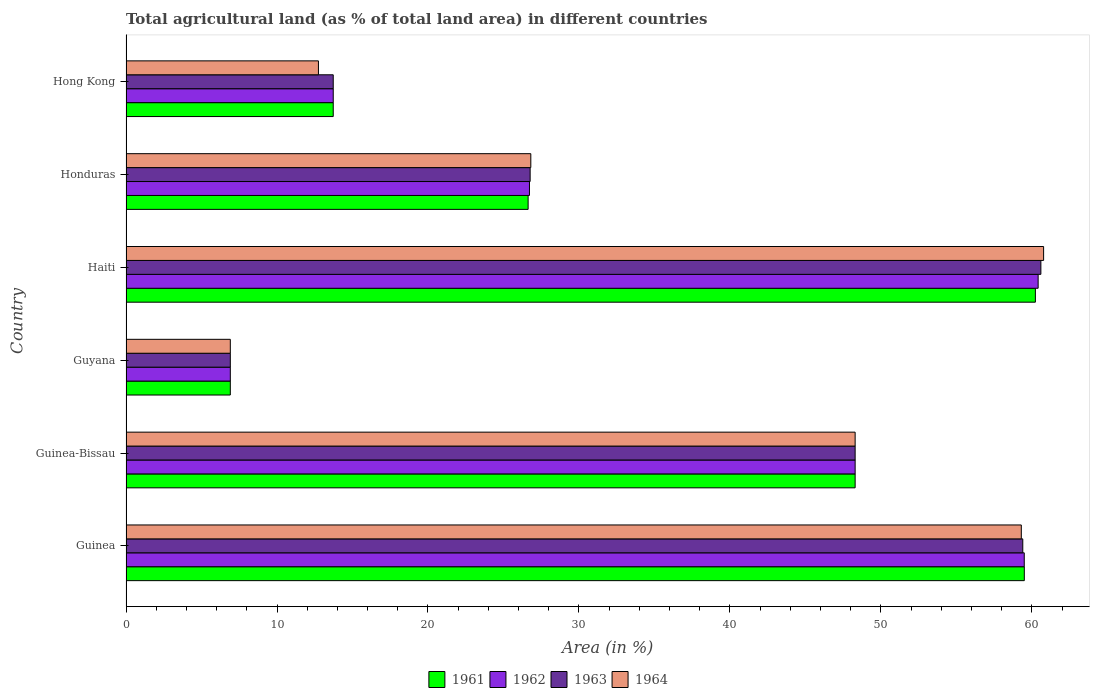How many groups of bars are there?
Your response must be concise. 6. What is the label of the 3rd group of bars from the top?
Your response must be concise. Haiti. In how many cases, is the number of bars for a given country not equal to the number of legend labels?
Your answer should be very brief. 0. What is the percentage of agricultural land in 1963 in Hong Kong?
Offer a very short reply. 13.73. Across all countries, what is the maximum percentage of agricultural land in 1961?
Provide a succinct answer. 60.23. Across all countries, what is the minimum percentage of agricultural land in 1961?
Make the answer very short. 6.91. In which country was the percentage of agricultural land in 1963 maximum?
Provide a succinct answer. Haiti. In which country was the percentage of agricultural land in 1964 minimum?
Keep it short and to the point. Guyana. What is the total percentage of agricultural land in 1962 in the graph?
Ensure brevity in your answer.  215.56. What is the difference between the percentage of agricultural land in 1963 in Guinea-Bissau and that in Hong Kong?
Ensure brevity in your answer.  34.57. What is the difference between the percentage of agricultural land in 1964 in Honduras and the percentage of agricultural land in 1961 in Hong Kong?
Offer a terse response. 13.09. What is the average percentage of agricultural land in 1963 per country?
Make the answer very short. 35.95. What is the difference between the percentage of agricultural land in 1964 and percentage of agricultural land in 1963 in Guinea?
Your response must be concise. -0.1. In how many countries, is the percentage of agricultural land in 1964 greater than 60 %?
Offer a very short reply. 1. What is the ratio of the percentage of agricultural land in 1963 in Haiti to that in Hong Kong?
Your answer should be very brief. 4.41. Is the percentage of agricultural land in 1962 in Guyana less than that in Hong Kong?
Offer a terse response. Yes. What is the difference between the highest and the second highest percentage of agricultural land in 1961?
Your answer should be compact. 0.73. What is the difference between the highest and the lowest percentage of agricultural land in 1964?
Make the answer very short. 53.87. Is the sum of the percentage of agricultural land in 1962 in Guinea-Bissau and Honduras greater than the maximum percentage of agricultural land in 1961 across all countries?
Your answer should be compact. Yes. Is it the case that in every country, the sum of the percentage of agricultural land in 1961 and percentage of agricultural land in 1964 is greater than the sum of percentage of agricultural land in 1963 and percentage of agricultural land in 1962?
Your answer should be very brief. No. What does the 3rd bar from the top in Guinea represents?
Your answer should be very brief. 1962. What does the 3rd bar from the bottom in Haiti represents?
Keep it short and to the point. 1963. Is it the case that in every country, the sum of the percentage of agricultural land in 1962 and percentage of agricultural land in 1963 is greater than the percentage of agricultural land in 1964?
Offer a very short reply. Yes. Does the graph contain grids?
Give a very brief answer. No. Where does the legend appear in the graph?
Your response must be concise. Bottom center. How many legend labels are there?
Your answer should be compact. 4. What is the title of the graph?
Ensure brevity in your answer.  Total agricultural land (as % of total land area) in different countries. Does "2000" appear as one of the legend labels in the graph?
Offer a very short reply. No. What is the label or title of the X-axis?
Provide a succinct answer. Area (in %). What is the Area (in %) in 1961 in Guinea?
Offer a terse response. 59.5. What is the Area (in %) in 1962 in Guinea?
Offer a very short reply. 59.49. What is the Area (in %) of 1963 in Guinea?
Offer a very short reply. 59.4. What is the Area (in %) of 1964 in Guinea?
Your answer should be compact. 59.3. What is the Area (in %) of 1961 in Guinea-Bissau?
Keep it short and to the point. 48.29. What is the Area (in %) of 1962 in Guinea-Bissau?
Give a very brief answer. 48.29. What is the Area (in %) of 1963 in Guinea-Bissau?
Offer a very short reply. 48.29. What is the Area (in %) of 1964 in Guinea-Bissau?
Provide a short and direct response. 48.29. What is the Area (in %) of 1961 in Guyana?
Your answer should be very brief. 6.91. What is the Area (in %) in 1962 in Guyana?
Provide a short and direct response. 6.91. What is the Area (in %) in 1963 in Guyana?
Your answer should be compact. 6.91. What is the Area (in %) of 1964 in Guyana?
Provide a short and direct response. 6.91. What is the Area (in %) of 1961 in Haiti?
Offer a terse response. 60.23. What is the Area (in %) of 1962 in Haiti?
Your answer should be very brief. 60.41. What is the Area (in %) in 1963 in Haiti?
Your answer should be compact. 60.6. What is the Area (in %) in 1964 in Haiti?
Provide a short and direct response. 60.78. What is the Area (in %) of 1961 in Honduras?
Ensure brevity in your answer.  26.63. What is the Area (in %) in 1962 in Honduras?
Your response must be concise. 26.72. What is the Area (in %) of 1963 in Honduras?
Provide a succinct answer. 26.77. What is the Area (in %) in 1964 in Honduras?
Offer a very short reply. 26.81. What is the Area (in %) in 1961 in Hong Kong?
Your answer should be very brief. 13.73. What is the Area (in %) of 1962 in Hong Kong?
Your response must be concise. 13.73. What is the Area (in %) of 1963 in Hong Kong?
Ensure brevity in your answer.  13.73. What is the Area (in %) of 1964 in Hong Kong?
Offer a terse response. 12.75. Across all countries, what is the maximum Area (in %) in 1961?
Your response must be concise. 60.23. Across all countries, what is the maximum Area (in %) in 1962?
Offer a very short reply. 60.41. Across all countries, what is the maximum Area (in %) in 1963?
Give a very brief answer. 60.6. Across all countries, what is the maximum Area (in %) in 1964?
Offer a terse response. 60.78. Across all countries, what is the minimum Area (in %) in 1961?
Your answer should be very brief. 6.91. Across all countries, what is the minimum Area (in %) of 1962?
Your answer should be compact. 6.91. Across all countries, what is the minimum Area (in %) in 1963?
Your answer should be very brief. 6.91. Across all countries, what is the minimum Area (in %) of 1964?
Make the answer very short. 6.91. What is the total Area (in %) in 1961 in the graph?
Keep it short and to the point. 215.29. What is the total Area (in %) of 1962 in the graph?
Ensure brevity in your answer.  215.56. What is the total Area (in %) in 1963 in the graph?
Ensure brevity in your answer.  215.69. What is the total Area (in %) in 1964 in the graph?
Ensure brevity in your answer.  214.83. What is the difference between the Area (in %) in 1961 in Guinea and that in Guinea-Bissau?
Your response must be concise. 11.21. What is the difference between the Area (in %) in 1962 in Guinea and that in Guinea-Bissau?
Offer a very short reply. 11.2. What is the difference between the Area (in %) in 1963 in Guinea and that in Guinea-Bissau?
Your answer should be compact. 11.1. What is the difference between the Area (in %) in 1964 in Guinea and that in Guinea-Bissau?
Offer a terse response. 11.01. What is the difference between the Area (in %) of 1961 in Guinea and that in Guyana?
Make the answer very short. 52.59. What is the difference between the Area (in %) of 1962 in Guinea and that in Guyana?
Your answer should be compact. 52.59. What is the difference between the Area (in %) in 1963 in Guinea and that in Guyana?
Provide a short and direct response. 52.49. What is the difference between the Area (in %) of 1964 in Guinea and that in Guyana?
Your answer should be compact. 52.39. What is the difference between the Area (in %) of 1961 in Guinea and that in Haiti?
Make the answer very short. -0.73. What is the difference between the Area (in %) in 1962 in Guinea and that in Haiti?
Ensure brevity in your answer.  -0.92. What is the difference between the Area (in %) in 1963 in Guinea and that in Haiti?
Offer a very short reply. -1.2. What is the difference between the Area (in %) of 1964 in Guinea and that in Haiti?
Make the answer very short. -1.48. What is the difference between the Area (in %) of 1961 in Guinea and that in Honduras?
Your answer should be very brief. 32.87. What is the difference between the Area (in %) in 1962 in Guinea and that in Honduras?
Give a very brief answer. 32.77. What is the difference between the Area (in %) of 1963 in Guinea and that in Honduras?
Make the answer very short. 32.63. What is the difference between the Area (in %) in 1964 in Guinea and that in Honduras?
Provide a succinct answer. 32.49. What is the difference between the Area (in %) in 1961 in Guinea and that in Hong Kong?
Your response must be concise. 45.77. What is the difference between the Area (in %) in 1962 in Guinea and that in Hong Kong?
Your answer should be very brief. 45.77. What is the difference between the Area (in %) in 1963 in Guinea and that in Hong Kong?
Offer a terse response. 45.67. What is the difference between the Area (in %) in 1964 in Guinea and that in Hong Kong?
Provide a succinct answer. 46.55. What is the difference between the Area (in %) of 1961 in Guinea-Bissau and that in Guyana?
Ensure brevity in your answer.  41.38. What is the difference between the Area (in %) of 1962 in Guinea-Bissau and that in Guyana?
Your response must be concise. 41.38. What is the difference between the Area (in %) of 1963 in Guinea-Bissau and that in Guyana?
Give a very brief answer. 41.38. What is the difference between the Area (in %) in 1964 in Guinea-Bissau and that in Guyana?
Your answer should be very brief. 41.38. What is the difference between the Area (in %) of 1961 in Guinea-Bissau and that in Haiti?
Offer a very short reply. -11.94. What is the difference between the Area (in %) in 1962 in Guinea-Bissau and that in Haiti?
Your response must be concise. -12.12. What is the difference between the Area (in %) in 1963 in Guinea-Bissau and that in Haiti?
Provide a succinct answer. -12.3. What is the difference between the Area (in %) in 1964 in Guinea-Bissau and that in Haiti?
Make the answer very short. -12.48. What is the difference between the Area (in %) in 1961 in Guinea-Bissau and that in Honduras?
Your answer should be compact. 21.66. What is the difference between the Area (in %) in 1962 in Guinea-Bissau and that in Honduras?
Provide a succinct answer. 21.57. What is the difference between the Area (in %) of 1963 in Guinea-Bissau and that in Honduras?
Give a very brief answer. 21.53. What is the difference between the Area (in %) of 1964 in Guinea-Bissau and that in Honduras?
Provide a short and direct response. 21.48. What is the difference between the Area (in %) of 1961 in Guinea-Bissau and that in Hong Kong?
Offer a terse response. 34.57. What is the difference between the Area (in %) of 1962 in Guinea-Bissau and that in Hong Kong?
Your answer should be very brief. 34.57. What is the difference between the Area (in %) in 1963 in Guinea-Bissau and that in Hong Kong?
Offer a terse response. 34.57. What is the difference between the Area (in %) in 1964 in Guinea-Bissau and that in Hong Kong?
Provide a succinct answer. 35.55. What is the difference between the Area (in %) in 1961 in Guyana and that in Haiti?
Give a very brief answer. -53.32. What is the difference between the Area (in %) in 1962 in Guyana and that in Haiti?
Provide a short and direct response. -53.51. What is the difference between the Area (in %) in 1963 in Guyana and that in Haiti?
Make the answer very short. -53.69. What is the difference between the Area (in %) in 1964 in Guyana and that in Haiti?
Ensure brevity in your answer.  -53.87. What is the difference between the Area (in %) in 1961 in Guyana and that in Honduras?
Give a very brief answer. -19.72. What is the difference between the Area (in %) of 1962 in Guyana and that in Honduras?
Your response must be concise. -19.81. What is the difference between the Area (in %) in 1963 in Guyana and that in Honduras?
Your answer should be very brief. -19.86. What is the difference between the Area (in %) of 1964 in Guyana and that in Honduras?
Your answer should be very brief. -19.9. What is the difference between the Area (in %) in 1961 in Guyana and that in Hong Kong?
Ensure brevity in your answer.  -6.82. What is the difference between the Area (in %) in 1962 in Guyana and that in Hong Kong?
Make the answer very short. -6.82. What is the difference between the Area (in %) in 1963 in Guyana and that in Hong Kong?
Give a very brief answer. -6.82. What is the difference between the Area (in %) of 1964 in Guyana and that in Hong Kong?
Provide a succinct answer. -5.84. What is the difference between the Area (in %) in 1961 in Haiti and that in Honduras?
Your answer should be compact. 33.6. What is the difference between the Area (in %) in 1962 in Haiti and that in Honduras?
Your response must be concise. 33.69. What is the difference between the Area (in %) of 1963 in Haiti and that in Honduras?
Keep it short and to the point. 33.83. What is the difference between the Area (in %) of 1964 in Haiti and that in Honduras?
Provide a succinct answer. 33.96. What is the difference between the Area (in %) of 1961 in Haiti and that in Hong Kong?
Provide a succinct answer. 46.51. What is the difference between the Area (in %) of 1962 in Haiti and that in Hong Kong?
Offer a terse response. 46.69. What is the difference between the Area (in %) in 1963 in Haiti and that in Hong Kong?
Your answer should be compact. 46.87. What is the difference between the Area (in %) of 1964 in Haiti and that in Hong Kong?
Your answer should be compact. 48.03. What is the difference between the Area (in %) of 1961 in Honduras and that in Hong Kong?
Your answer should be very brief. 12.91. What is the difference between the Area (in %) in 1962 in Honduras and that in Hong Kong?
Provide a succinct answer. 13. What is the difference between the Area (in %) in 1963 in Honduras and that in Hong Kong?
Offer a terse response. 13.04. What is the difference between the Area (in %) in 1964 in Honduras and that in Hong Kong?
Make the answer very short. 14.07. What is the difference between the Area (in %) in 1961 in Guinea and the Area (in %) in 1962 in Guinea-Bissau?
Provide a succinct answer. 11.21. What is the difference between the Area (in %) in 1961 in Guinea and the Area (in %) in 1963 in Guinea-Bissau?
Offer a very short reply. 11.21. What is the difference between the Area (in %) of 1961 in Guinea and the Area (in %) of 1964 in Guinea-Bissau?
Provide a short and direct response. 11.21. What is the difference between the Area (in %) of 1962 in Guinea and the Area (in %) of 1963 in Guinea-Bissau?
Your answer should be very brief. 11.2. What is the difference between the Area (in %) of 1962 in Guinea and the Area (in %) of 1964 in Guinea-Bissau?
Your response must be concise. 11.2. What is the difference between the Area (in %) in 1963 in Guinea and the Area (in %) in 1964 in Guinea-Bissau?
Your answer should be very brief. 11.1. What is the difference between the Area (in %) of 1961 in Guinea and the Area (in %) of 1962 in Guyana?
Offer a very short reply. 52.59. What is the difference between the Area (in %) of 1961 in Guinea and the Area (in %) of 1963 in Guyana?
Make the answer very short. 52.59. What is the difference between the Area (in %) of 1961 in Guinea and the Area (in %) of 1964 in Guyana?
Your response must be concise. 52.59. What is the difference between the Area (in %) of 1962 in Guinea and the Area (in %) of 1963 in Guyana?
Your answer should be very brief. 52.59. What is the difference between the Area (in %) in 1962 in Guinea and the Area (in %) in 1964 in Guyana?
Keep it short and to the point. 52.59. What is the difference between the Area (in %) of 1963 in Guinea and the Area (in %) of 1964 in Guyana?
Offer a terse response. 52.49. What is the difference between the Area (in %) in 1961 in Guinea and the Area (in %) in 1962 in Haiti?
Your answer should be compact. -0.92. What is the difference between the Area (in %) of 1961 in Guinea and the Area (in %) of 1963 in Haiti?
Offer a very short reply. -1.1. What is the difference between the Area (in %) of 1961 in Guinea and the Area (in %) of 1964 in Haiti?
Give a very brief answer. -1.28. What is the difference between the Area (in %) of 1962 in Guinea and the Area (in %) of 1963 in Haiti?
Keep it short and to the point. -1.1. What is the difference between the Area (in %) of 1962 in Guinea and the Area (in %) of 1964 in Haiti?
Offer a terse response. -1.28. What is the difference between the Area (in %) of 1963 in Guinea and the Area (in %) of 1964 in Haiti?
Give a very brief answer. -1.38. What is the difference between the Area (in %) in 1961 in Guinea and the Area (in %) in 1962 in Honduras?
Give a very brief answer. 32.78. What is the difference between the Area (in %) of 1961 in Guinea and the Area (in %) of 1963 in Honduras?
Ensure brevity in your answer.  32.73. What is the difference between the Area (in %) of 1961 in Guinea and the Area (in %) of 1964 in Honduras?
Ensure brevity in your answer.  32.69. What is the difference between the Area (in %) in 1962 in Guinea and the Area (in %) in 1963 in Honduras?
Your response must be concise. 32.73. What is the difference between the Area (in %) in 1962 in Guinea and the Area (in %) in 1964 in Honduras?
Offer a very short reply. 32.68. What is the difference between the Area (in %) of 1963 in Guinea and the Area (in %) of 1964 in Honduras?
Your answer should be very brief. 32.58. What is the difference between the Area (in %) in 1961 in Guinea and the Area (in %) in 1962 in Hong Kong?
Your response must be concise. 45.77. What is the difference between the Area (in %) in 1961 in Guinea and the Area (in %) in 1963 in Hong Kong?
Offer a very short reply. 45.77. What is the difference between the Area (in %) in 1961 in Guinea and the Area (in %) in 1964 in Hong Kong?
Your answer should be very brief. 46.75. What is the difference between the Area (in %) of 1962 in Guinea and the Area (in %) of 1963 in Hong Kong?
Your answer should be very brief. 45.77. What is the difference between the Area (in %) of 1962 in Guinea and the Area (in %) of 1964 in Hong Kong?
Provide a short and direct response. 46.75. What is the difference between the Area (in %) of 1963 in Guinea and the Area (in %) of 1964 in Hong Kong?
Your response must be concise. 46.65. What is the difference between the Area (in %) in 1961 in Guinea-Bissau and the Area (in %) in 1962 in Guyana?
Your answer should be compact. 41.38. What is the difference between the Area (in %) of 1961 in Guinea-Bissau and the Area (in %) of 1963 in Guyana?
Offer a terse response. 41.38. What is the difference between the Area (in %) of 1961 in Guinea-Bissau and the Area (in %) of 1964 in Guyana?
Offer a very short reply. 41.38. What is the difference between the Area (in %) in 1962 in Guinea-Bissau and the Area (in %) in 1963 in Guyana?
Make the answer very short. 41.38. What is the difference between the Area (in %) of 1962 in Guinea-Bissau and the Area (in %) of 1964 in Guyana?
Your answer should be very brief. 41.38. What is the difference between the Area (in %) in 1963 in Guinea-Bissau and the Area (in %) in 1964 in Guyana?
Your answer should be very brief. 41.38. What is the difference between the Area (in %) in 1961 in Guinea-Bissau and the Area (in %) in 1962 in Haiti?
Keep it short and to the point. -12.12. What is the difference between the Area (in %) of 1961 in Guinea-Bissau and the Area (in %) of 1963 in Haiti?
Ensure brevity in your answer.  -12.3. What is the difference between the Area (in %) in 1961 in Guinea-Bissau and the Area (in %) in 1964 in Haiti?
Provide a short and direct response. -12.48. What is the difference between the Area (in %) of 1962 in Guinea-Bissau and the Area (in %) of 1963 in Haiti?
Offer a very short reply. -12.3. What is the difference between the Area (in %) of 1962 in Guinea-Bissau and the Area (in %) of 1964 in Haiti?
Ensure brevity in your answer.  -12.48. What is the difference between the Area (in %) in 1963 in Guinea-Bissau and the Area (in %) in 1964 in Haiti?
Your response must be concise. -12.48. What is the difference between the Area (in %) in 1961 in Guinea-Bissau and the Area (in %) in 1962 in Honduras?
Ensure brevity in your answer.  21.57. What is the difference between the Area (in %) of 1961 in Guinea-Bissau and the Area (in %) of 1963 in Honduras?
Give a very brief answer. 21.53. What is the difference between the Area (in %) of 1961 in Guinea-Bissau and the Area (in %) of 1964 in Honduras?
Give a very brief answer. 21.48. What is the difference between the Area (in %) of 1962 in Guinea-Bissau and the Area (in %) of 1963 in Honduras?
Your answer should be compact. 21.53. What is the difference between the Area (in %) in 1962 in Guinea-Bissau and the Area (in %) in 1964 in Honduras?
Make the answer very short. 21.48. What is the difference between the Area (in %) of 1963 in Guinea-Bissau and the Area (in %) of 1964 in Honduras?
Give a very brief answer. 21.48. What is the difference between the Area (in %) of 1961 in Guinea-Bissau and the Area (in %) of 1962 in Hong Kong?
Provide a short and direct response. 34.57. What is the difference between the Area (in %) in 1961 in Guinea-Bissau and the Area (in %) in 1963 in Hong Kong?
Provide a succinct answer. 34.57. What is the difference between the Area (in %) in 1961 in Guinea-Bissau and the Area (in %) in 1964 in Hong Kong?
Keep it short and to the point. 35.55. What is the difference between the Area (in %) in 1962 in Guinea-Bissau and the Area (in %) in 1963 in Hong Kong?
Provide a short and direct response. 34.57. What is the difference between the Area (in %) of 1962 in Guinea-Bissau and the Area (in %) of 1964 in Hong Kong?
Offer a terse response. 35.55. What is the difference between the Area (in %) in 1963 in Guinea-Bissau and the Area (in %) in 1964 in Hong Kong?
Offer a terse response. 35.55. What is the difference between the Area (in %) in 1961 in Guyana and the Area (in %) in 1962 in Haiti?
Ensure brevity in your answer.  -53.51. What is the difference between the Area (in %) in 1961 in Guyana and the Area (in %) in 1963 in Haiti?
Give a very brief answer. -53.69. What is the difference between the Area (in %) in 1961 in Guyana and the Area (in %) in 1964 in Haiti?
Make the answer very short. -53.87. What is the difference between the Area (in %) in 1962 in Guyana and the Area (in %) in 1963 in Haiti?
Give a very brief answer. -53.69. What is the difference between the Area (in %) of 1962 in Guyana and the Area (in %) of 1964 in Haiti?
Provide a succinct answer. -53.87. What is the difference between the Area (in %) of 1963 in Guyana and the Area (in %) of 1964 in Haiti?
Offer a very short reply. -53.87. What is the difference between the Area (in %) in 1961 in Guyana and the Area (in %) in 1962 in Honduras?
Your answer should be very brief. -19.81. What is the difference between the Area (in %) in 1961 in Guyana and the Area (in %) in 1963 in Honduras?
Offer a terse response. -19.86. What is the difference between the Area (in %) in 1961 in Guyana and the Area (in %) in 1964 in Honduras?
Keep it short and to the point. -19.9. What is the difference between the Area (in %) of 1962 in Guyana and the Area (in %) of 1963 in Honduras?
Make the answer very short. -19.86. What is the difference between the Area (in %) of 1962 in Guyana and the Area (in %) of 1964 in Honduras?
Offer a very short reply. -19.9. What is the difference between the Area (in %) in 1963 in Guyana and the Area (in %) in 1964 in Honduras?
Make the answer very short. -19.9. What is the difference between the Area (in %) in 1961 in Guyana and the Area (in %) in 1962 in Hong Kong?
Your response must be concise. -6.82. What is the difference between the Area (in %) of 1961 in Guyana and the Area (in %) of 1963 in Hong Kong?
Offer a very short reply. -6.82. What is the difference between the Area (in %) in 1961 in Guyana and the Area (in %) in 1964 in Hong Kong?
Your response must be concise. -5.84. What is the difference between the Area (in %) in 1962 in Guyana and the Area (in %) in 1963 in Hong Kong?
Make the answer very short. -6.82. What is the difference between the Area (in %) of 1962 in Guyana and the Area (in %) of 1964 in Hong Kong?
Provide a succinct answer. -5.84. What is the difference between the Area (in %) in 1963 in Guyana and the Area (in %) in 1964 in Hong Kong?
Make the answer very short. -5.84. What is the difference between the Area (in %) of 1961 in Haiti and the Area (in %) of 1962 in Honduras?
Provide a short and direct response. 33.51. What is the difference between the Area (in %) in 1961 in Haiti and the Area (in %) in 1963 in Honduras?
Make the answer very short. 33.46. What is the difference between the Area (in %) in 1961 in Haiti and the Area (in %) in 1964 in Honduras?
Keep it short and to the point. 33.42. What is the difference between the Area (in %) of 1962 in Haiti and the Area (in %) of 1963 in Honduras?
Make the answer very short. 33.65. What is the difference between the Area (in %) of 1962 in Haiti and the Area (in %) of 1964 in Honduras?
Offer a terse response. 33.6. What is the difference between the Area (in %) in 1963 in Haiti and the Area (in %) in 1964 in Honduras?
Make the answer very short. 33.78. What is the difference between the Area (in %) in 1961 in Haiti and the Area (in %) in 1962 in Hong Kong?
Keep it short and to the point. 46.51. What is the difference between the Area (in %) of 1961 in Haiti and the Area (in %) of 1963 in Hong Kong?
Your answer should be compact. 46.51. What is the difference between the Area (in %) of 1961 in Haiti and the Area (in %) of 1964 in Hong Kong?
Provide a short and direct response. 47.49. What is the difference between the Area (in %) of 1962 in Haiti and the Area (in %) of 1963 in Hong Kong?
Your answer should be very brief. 46.69. What is the difference between the Area (in %) in 1962 in Haiti and the Area (in %) in 1964 in Hong Kong?
Your answer should be compact. 47.67. What is the difference between the Area (in %) of 1963 in Haiti and the Area (in %) of 1964 in Hong Kong?
Offer a terse response. 47.85. What is the difference between the Area (in %) of 1961 in Honduras and the Area (in %) of 1962 in Hong Kong?
Keep it short and to the point. 12.91. What is the difference between the Area (in %) of 1961 in Honduras and the Area (in %) of 1963 in Hong Kong?
Offer a terse response. 12.91. What is the difference between the Area (in %) in 1961 in Honduras and the Area (in %) in 1964 in Hong Kong?
Offer a terse response. 13.89. What is the difference between the Area (in %) in 1962 in Honduras and the Area (in %) in 1963 in Hong Kong?
Offer a very short reply. 13. What is the difference between the Area (in %) in 1962 in Honduras and the Area (in %) in 1964 in Hong Kong?
Make the answer very short. 13.98. What is the difference between the Area (in %) in 1963 in Honduras and the Area (in %) in 1964 in Hong Kong?
Keep it short and to the point. 14.02. What is the average Area (in %) in 1961 per country?
Offer a terse response. 35.88. What is the average Area (in %) in 1962 per country?
Make the answer very short. 35.93. What is the average Area (in %) of 1963 per country?
Keep it short and to the point. 35.95. What is the average Area (in %) in 1964 per country?
Ensure brevity in your answer.  35.81. What is the difference between the Area (in %) in 1961 and Area (in %) in 1962 in Guinea?
Give a very brief answer. 0. What is the difference between the Area (in %) of 1961 and Area (in %) of 1963 in Guinea?
Your answer should be compact. 0.1. What is the difference between the Area (in %) of 1961 and Area (in %) of 1964 in Guinea?
Provide a short and direct response. 0.2. What is the difference between the Area (in %) in 1962 and Area (in %) in 1963 in Guinea?
Make the answer very short. 0.1. What is the difference between the Area (in %) of 1962 and Area (in %) of 1964 in Guinea?
Keep it short and to the point. 0.2. What is the difference between the Area (in %) in 1963 and Area (in %) in 1964 in Guinea?
Your answer should be very brief. 0.1. What is the difference between the Area (in %) in 1963 and Area (in %) in 1964 in Guinea-Bissau?
Ensure brevity in your answer.  0. What is the difference between the Area (in %) of 1961 and Area (in %) of 1963 in Guyana?
Keep it short and to the point. 0. What is the difference between the Area (in %) of 1961 and Area (in %) of 1964 in Guyana?
Your answer should be very brief. 0. What is the difference between the Area (in %) in 1963 and Area (in %) in 1964 in Guyana?
Your response must be concise. 0. What is the difference between the Area (in %) in 1961 and Area (in %) in 1962 in Haiti?
Ensure brevity in your answer.  -0.18. What is the difference between the Area (in %) of 1961 and Area (in %) of 1963 in Haiti?
Keep it short and to the point. -0.36. What is the difference between the Area (in %) of 1961 and Area (in %) of 1964 in Haiti?
Make the answer very short. -0.54. What is the difference between the Area (in %) in 1962 and Area (in %) in 1963 in Haiti?
Your answer should be compact. -0.18. What is the difference between the Area (in %) in 1962 and Area (in %) in 1964 in Haiti?
Your answer should be very brief. -0.36. What is the difference between the Area (in %) of 1963 and Area (in %) of 1964 in Haiti?
Make the answer very short. -0.18. What is the difference between the Area (in %) in 1961 and Area (in %) in 1962 in Honduras?
Provide a succinct answer. -0.09. What is the difference between the Area (in %) of 1961 and Area (in %) of 1963 in Honduras?
Your response must be concise. -0.13. What is the difference between the Area (in %) of 1961 and Area (in %) of 1964 in Honduras?
Give a very brief answer. -0.18. What is the difference between the Area (in %) of 1962 and Area (in %) of 1963 in Honduras?
Give a very brief answer. -0.04. What is the difference between the Area (in %) in 1962 and Area (in %) in 1964 in Honduras?
Your answer should be compact. -0.09. What is the difference between the Area (in %) of 1963 and Area (in %) of 1964 in Honduras?
Provide a succinct answer. -0.04. What is the difference between the Area (in %) of 1961 and Area (in %) of 1963 in Hong Kong?
Offer a very short reply. 0. What is the difference between the Area (in %) of 1961 and Area (in %) of 1964 in Hong Kong?
Offer a very short reply. 0.98. What is the difference between the Area (in %) in 1962 and Area (in %) in 1964 in Hong Kong?
Offer a terse response. 0.98. What is the difference between the Area (in %) of 1963 and Area (in %) of 1964 in Hong Kong?
Offer a terse response. 0.98. What is the ratio of the Area (in %) in 1961 in Guinea to that in Guinea-Bissau?
Ensure brevity in your answer.  1.23. What is the ratio of the Area (in %) in 1962 in Guinea to that in Guinea-Bissau?
Your response must be concise. 1.23. What is the ratio of the Area (in %) of 1963 in Guinea to that in Guinea-Bissau?
Provide a short and direct response. 1.23. What is the ratio of the Area (in %) of 1964 in Guinea to that in Guinea-Bissau?
Your response must be concise. 1.23. What is the ratio of the Area (in %) of 1961 in Guinea to that in Guyana?
Ensure brevity in your answer.  8.61. What is the ratio of the Area (in %) in 1962 in Guinea to that in Guyana?
Provide a succinct answer. 8.61. What is the ratio of the Area (in %) in 1963 in Guinea to that in Guyana?
Give a very brief answer. 8.6. What is the ratio of the Area (in %) in 1964 in Guinea to that in Guyana?
Provide a short and direct response. 8.58. What is the ratio of the Area (in %) of 1963 in Guinea to that in Haiti?
Make the answer very short. 0.98. What is the ratio of the Area (in %) of 1964 in Guinea to that in Haiti?
Give a very brief answer. 0.98. What is the ratio of the Area (in %) of 1961 in Guinea to that in Honduras?
Your response must be concise. 2.23. What is the ratio of the Area (in %) in 1962 in Guinea to that in Honduras?
Your answer should be very brief. 2.23. What is the ratio of the Area (in %) of 1963 in Guinea to that in Honduras?
Provide a short and direct response. 2.22. What is the ratio of the Area (in %) in 1964 in Guinea to that in Honduras?
Make the answer very short. 2.21. What is the ratio of the Area (in %) in 1961 in Guinea to that in Hong Kong?
Your response must be concise. 4.33. What is the ratio of the Area (in %) of 1962 in Guinea to that in Hong Kong?
Offer a terse response. 4.33. What is the ratio of the Area (in %) in 1963 in Guinea to that in Hong Kong?
Provide a succinct answer. 4.33. What is the ratio of the Area (in %) in 1964 in Guinea to that in Hong Kong?
Offer a very short reply. 4.65. What is the ratio of the Area (in %) of 1961 in Guinea-Bissau to that in Guyana?
Your answer should be compact. 6.99. What is the ratio of the Area (in %) of 1962 in Guinea-Bissau to that in Guyana?
Your response must be concise. 6.99. What is the ratio of the Area (in %) of 1963 in Guinea-Bissau to that in Guyana?
Give a very brief answer. 6.99. What is the ratio of the Area (in %) in 1964 in Guinea-Bissau to that in Guyana?
Give a very brief answer. 6.99. What is the ratio of the Area (in %) in 1961 in Guinea-Bissau to that in Haiti?
Keep it short and to the point. 0.8. What is the ratio of the Area (in %) in 1962 in Guinea-Bissau to that in Haiti?
Your answer should be compact. 0.8. What is the ratio of the Area (in %) in 1963 in Guinea-Bissau to that in Haiti?
Your response must be concise. 0.8. What is the ratio of the Area (in %) of 1964 in Guinea-Bissau to that in Haiti?
Provide a short and direct response. 0.79. What is the ratio of the Area (in %) of 1961 in Guinea-Bissau to that in Honduras?
Ensure brevity in your answer.  1.81. What is the ratio of the Area (in %) in 1962 in Guinea-Bissau to that in Honduras?
Ensure brevity in your answer.  1.81. What is the ratio of the Area (in %) of 1963 in Guinea-Bissau to that in Honduras?
Ensure brevity in your answer.  1.8. What is the ratio of the Area (in %) of 1964 in Guinea-Bissau to that in Honduras?
Your response must be concise. 1.8. What is the ratio of the Area (in %) of 1961 in Guinea-Bissau to that in Hong Kong?
Provide a succinct answer. 3.52. What is the ratio of the Area (in %) in 1962 in Guinea-Bissau to that in Hong Kong?
Provide a short and direct response. 3.52. What is the ratio of the Area (in %) in 1963 in Guinea-Bissau to that in Hong Kong?
Offer a very short reply. 3.52. What is the ratio of the Area (in %) of 1964 in Guinea-Bissau to that in Hong Kong?
Your answer should be compact. 3.79. What is the ratio of the Area (in %) of 1961 in Guyana to that in Haiti?
Offer a terse response. 0.11. What is the ratio of the Area (in %) in 1962 in Guyana to that in Haiti?
Provide a succinct answer. 0.11. What is the ratio of the Area (in %) in 1963 in Guyana to that in Haiti?
Your response must be concise. 0.11. What is the ratio of the Area (in %) of 1964 in Guyana to that in Haiti?
Your answer should be compact. 0.11. What is the ratio of the Area (in %) in 1961 in Guyana to that in Honduras?
Your answer should be very brief. 0.26. What is the ratio of the Area (in %) of 1962 in Guyana to that in Honduras?
Give a very brief answer. 0.26. What is the ratio of the Area (in %) in 1963 in Guyana to that in Honduras?
Provide a short and direct response. 0.26. What is the ratio of the Area (in %) in 1964 in Guyana to that in Honduras?
Ensure brevity in your answer.  0.26. What is the ratio of the Area (in %) in 1961 in Guyana to that in Hong Kong?
Offer a very short reply. 0.5. What is the ratio of the Area (in %) in 1962 in Guyana to that in Hong Kong?
Offer a terse response. 0.5. What is the ratio of the Area (in %) in 1963 in Guyana to that in Hong Kong?
Give a very brief answer. 0.5. What is the ratio of the Area (in %) in 1964 in Guyana to that in Hong Kong?
Make the answer very short. 0.54. What is the ratio of the Area (in %) of 1961 in Haiti to that in Honduras?
Give a very brief answer. 2.26. What is the ratio of the Area (in %) of 1962 in Haiti to that in Honduras?
Your response must be concise. 2.26. What is the ratio of the Area (in %) of 1963 in Haiti to that in Honduras?
Give a very brief answer. 2.26. What is the ratio of the Area (in %) in 1964 in Haiti to that in Honduras?
Your answer should be compact. 2.27. What is the ratio of the Area (in %) of 1961 in Haiti to that in Hong Kong?
Ensure brevity in your answer.  4.39. What is the ratio of the Area (in %) in 1962 in Haiti to that in Hong Kong?
Make the answer very short. 4.4. What is the ratio of the Area (in %) of 1963 in Haiti to that in Hong Kong?
Provide a short and direct response. 4.41. What is the ratio of the Area (in %) in 1964 in Haiti to that in Hong Kong?
Your response must be concise. 4.77. What is the ratio of the Area (in %) of 1961 in Honduras to that in Hong Kong?
Provide a succinct answer. 1.94. What is the ratio of the Area (in %) of 1962 in Honduras to that in Hong Kong?
Keep it short and to the point. 1.95. What is the ratio of the Area (in %) in 1963 in Honduras to that in Hong Kong?
Keep it short and to the point. 1.95. What is the ratio of the Area (in %) in 1964 in Honduras to that in Hong Kong?
Give a very brief answer. 2.1. What is the difference between the highest and the second highest Area (in %) of 1961?
Keep it short and to the point. 0.73. What is the difference between the highest and the second highest Area (in %) in 1962?
Give a very brief answer. 0.92. What is the difference between the highest and the second highest Area (in %) of 1963?
Keep it short and to the point. 1.2. What is the difference between the highest and the second highest Area (in %) in 1964?
Offer a terse response. 1.48. What is the difference between the highest and the lowest Area (in %) of 1961?
Offer a very short reply. 53.32. What is the difference between the highest and the lowest Area (in %) of 1962?
Offer a terse response. 53.51. What is the difference between the highest and the lowest Area (in %) in 1963?
Ensure brevity in your answer.  53.69. What is the difference between the highest and the lowest Area (in %) in 1964?
Ensure brevity in your answer.  53.87. 